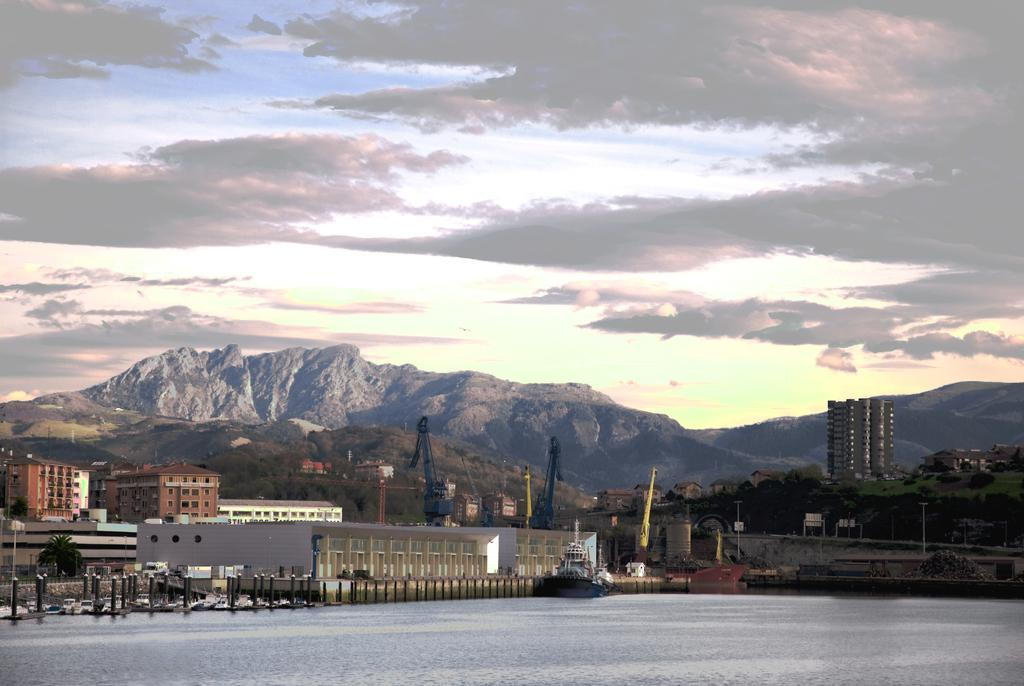What type of structures can be seen in the image? There are buildings in the image. What natural elements are present in the image? There are trees and hills visible in the image. What construction equipment is present in the image? Tower cranes are present in the image. What are the poles used for in the image? The purpose of the poles is not specified in the image, but they could be used for various purposes such as lighting or signage. What is on the water at the bottom of the image? There is a boat on the water at the bottom of the image. What part of the natural environment is visible in the background of the image? The sky is visible in the background of the image. What type of sign can be seen on the tongue of the plantation worker in the image? There is no sign or plantation worker present in the image. How many plantation workers are visible in the image? There are no plantation workers present in the image. 